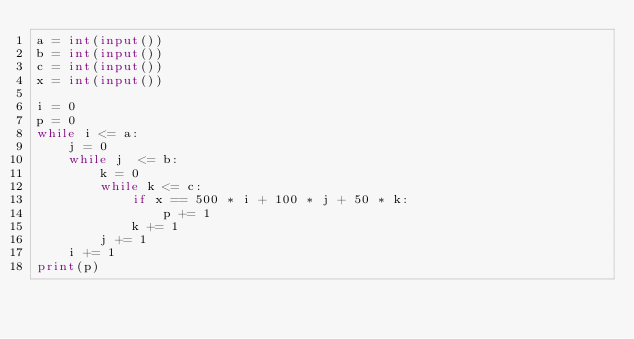<code> <loc_0><loc_0><loc_500><loc_500><_Python_>a = int(input())
b = int(input())
c = int(input())
x = int(input())

i = 0
p = 0
while i <= a:
    j = 0
    while j  <= b:
        k = 0
        while k <= c:
            if x == 500 * i + 100 * j + 50 * k:
                p += 1
            k += 1
        j += 1
    i += 1
print(p)
</code> 